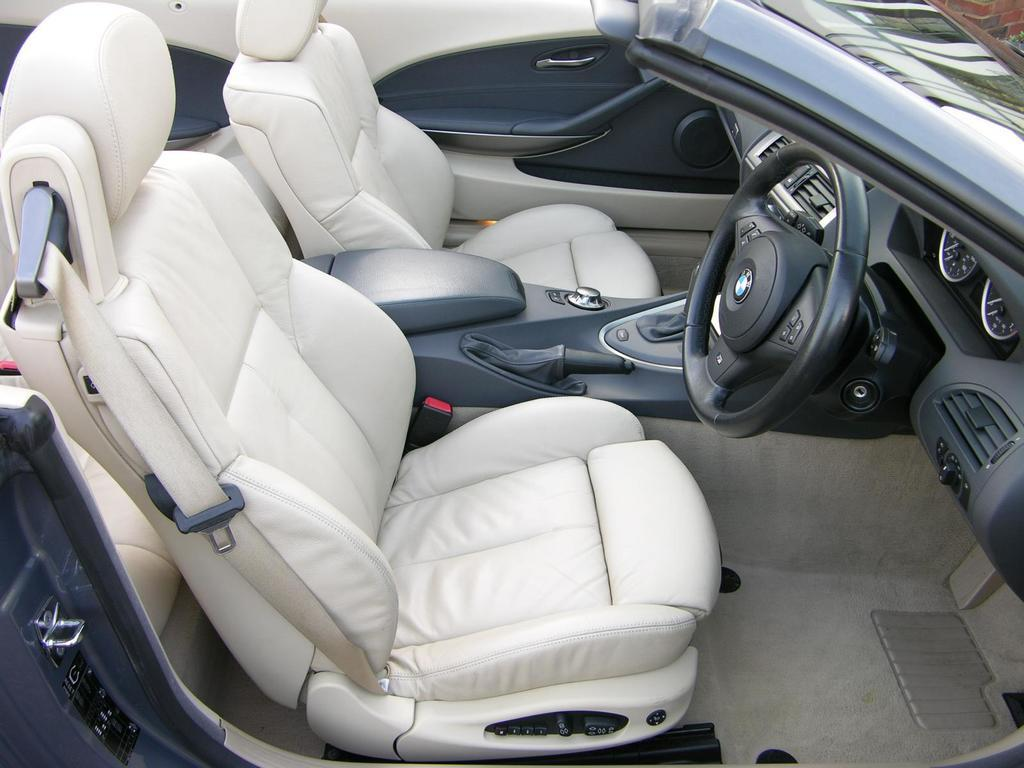What type of vehicle is shown in the image? The image shows an inner view of a car. What can be found inside the car? There are seats in the car. What is used to control the direction of the car? A steering wheel is present in the car. How does the driver change the speed of the car? There is a gear in the car. What type of digestion can be observed in the image? There is no digestion present in the image, as it shows the interior of a car. What smell is associated with the image? The image does not convey any specific smell. 